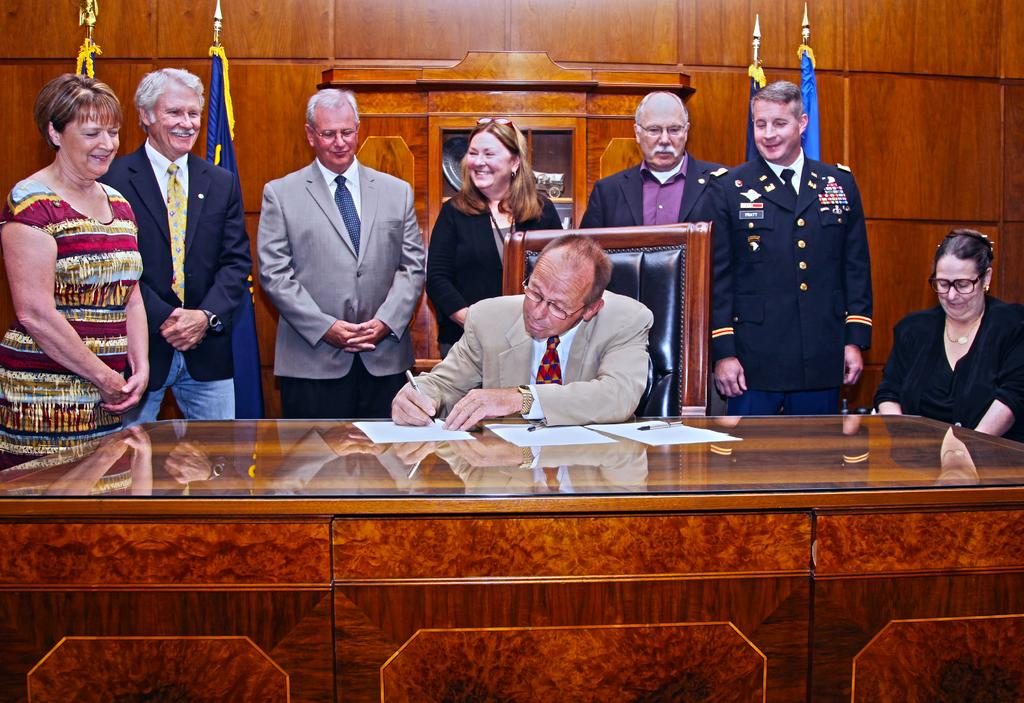What is the person in the image doing? There is a person sitting at the table in the image. What can be seen in the background of the image? There are persons standing and flags visible in the background of the image. What is the background of the image composed of? There is a wall in the background of the image. What type of beam is being used to support the table in the image? There is no beam visible in the image, and the table's support is not mentioned in the provided facts. 